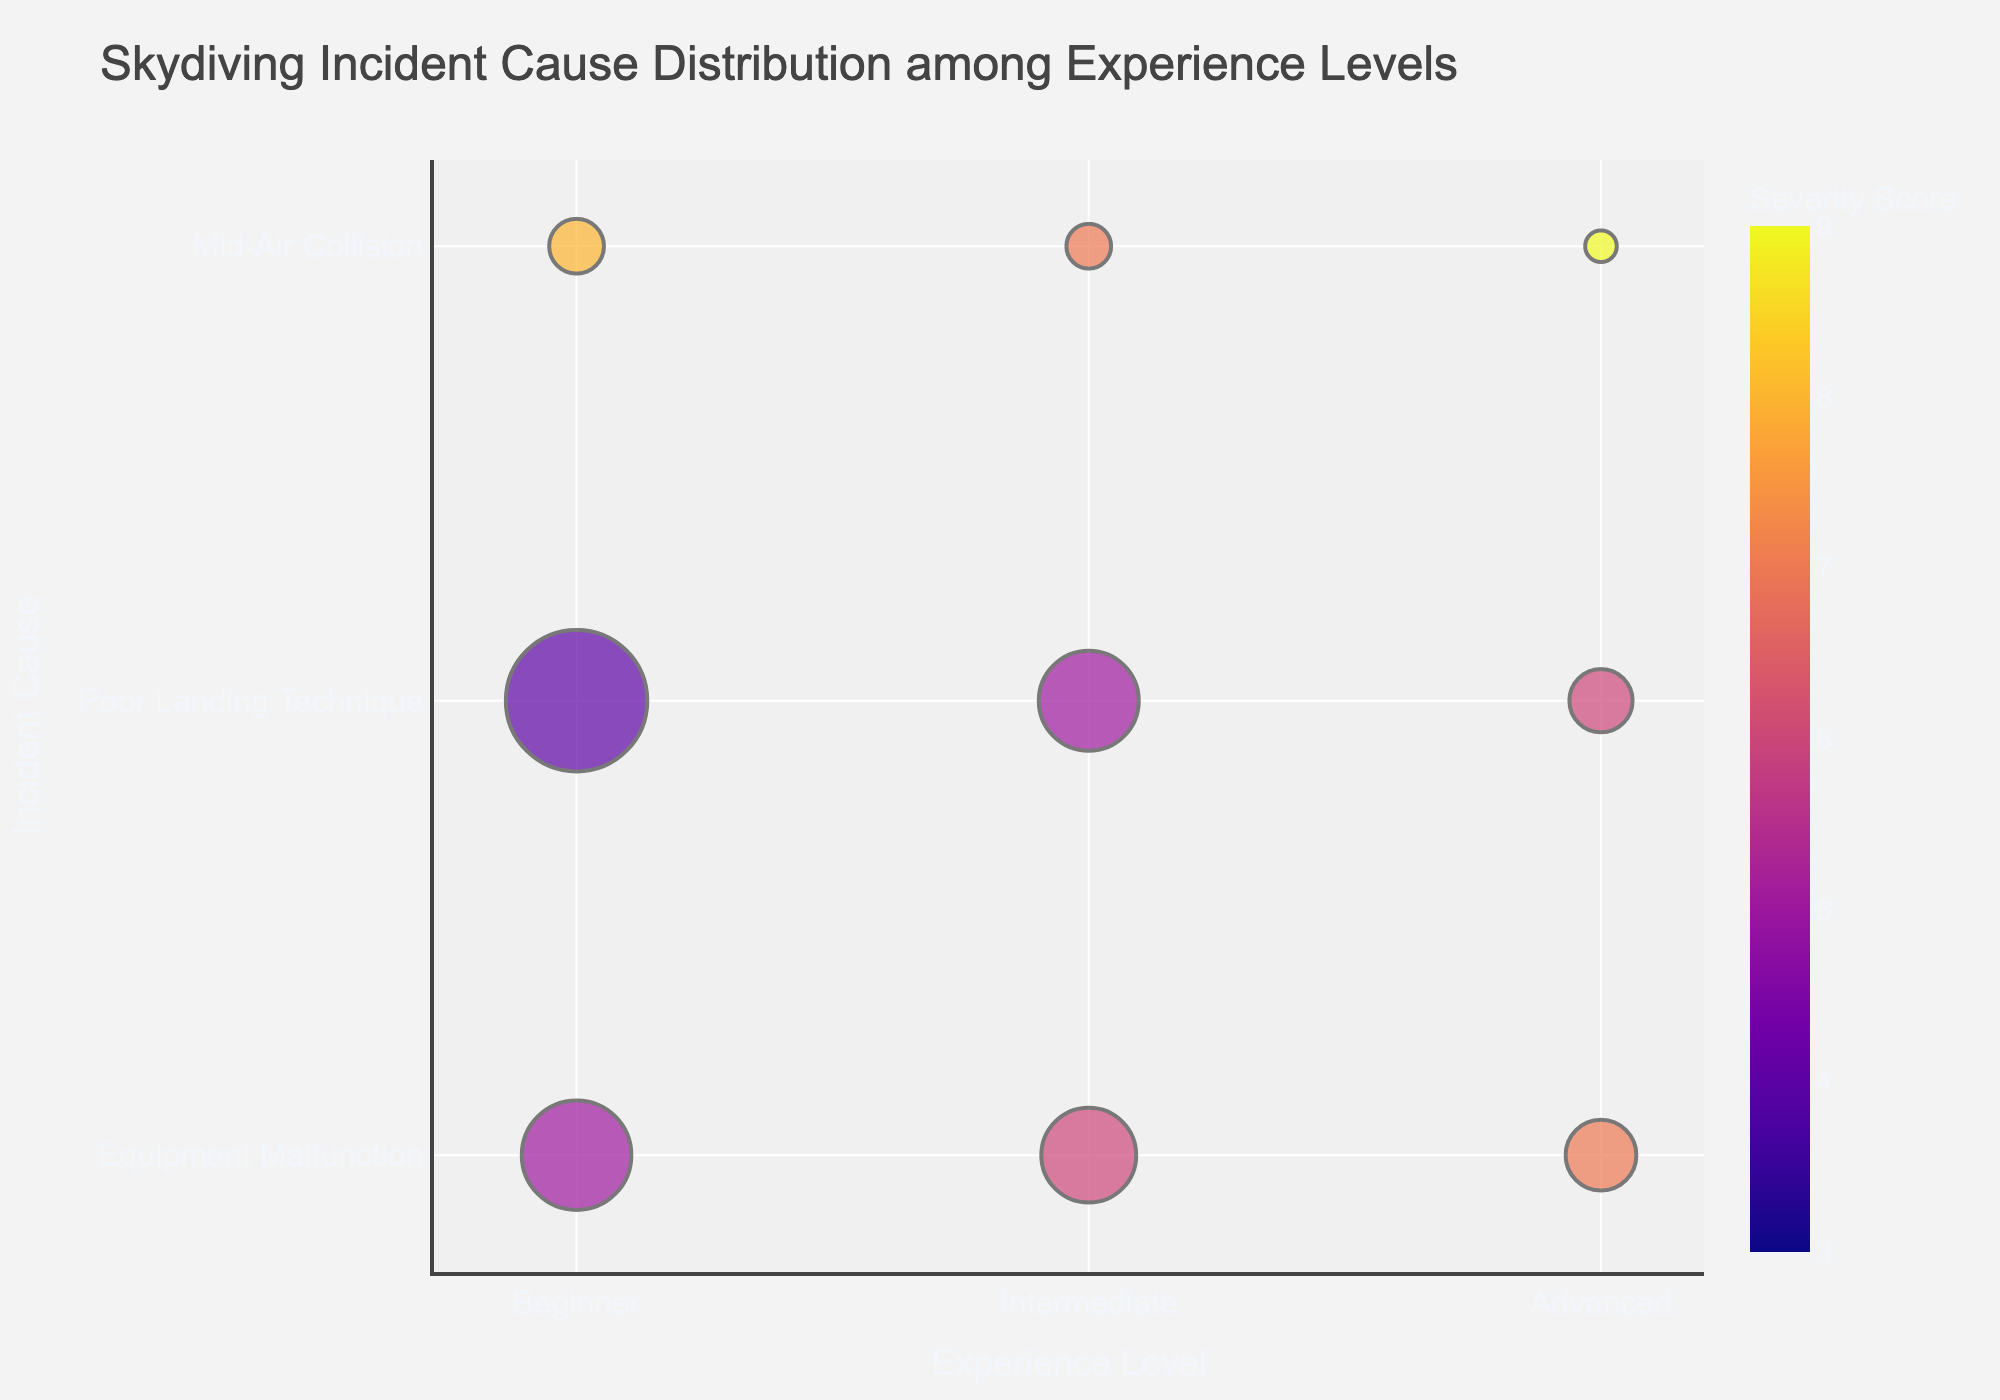What's the title of the bubble chart? The title of the bubble chart is usually displayed at the top of the figure. In this case, it specifically tells us what the chart is about.
Answer: Skydiving Incident Cause Distribution among Experience Levels How many incident causes are there for beginners? Look at the bubbles on the "Beginner" row in the y-axis. Count the distinct incident causes linked to this experience level.
Answer: 3 Which experience level has the highest number of incidents for "Poor Landing Technique"? Examine the size of the bubbles corresponding to "Poor Landing Technique" along the y-axis for each experience level. The largest bubble indicates the highest number of incidents.
Answer: Beginner What's the total number of incidents for "Equipment Malfunction" across all experience levels? Add up the sizes of the bubbles aligned with "Equipment Malfunction" for all experience levels. The individual counts are 12, 9, and 5. Their sum is 12 + 9 + 5 = 26.
Answer: 26 Which incident cause has the highest severity for advanced skydivers? Look at the "Advanced" row, then identify the bubble with the highest color intensity (which corresponds to higher severity).
Answer: Mid-Air Collision Compare the number of incidents for "Mid-Air Collision" between beginners and intermediates. Which group has more incidents? Identify the bubbles representing "Mid-Air Collision" for beginners and intermediates, then compare their sizes. Beginners have 3 incidents, while intermediates have 2.
Answer: Beginners What is the average severity score for "Poor Landing Technique" incidents? Note the severity for "Poor Landing Technique" across all experience levels (4, 5, and 6), then compute the average: (4 + 5 + 6) / 3 = 5.
Answer: 5 Which incident cause has both the lowest number and the highest severity for advanced skydivers? For advanced skydivers, identify the bubble corresponding to each incident cause. The smallest bubble with the highest color intensity indicates 1 incident and severity 9.
Answer: Mid-Air Collision How does the number of incidents for "Equipment Malfunction" compare between beginners and advanced skydivers? Look at the sizes of the bubbles for "Equipment Malfunction" in the beginner and advanced rows. Beginners have 12 incidents, and advanced skydivers have 5. 12 is greater than 5.
Answer: Beginners have more incidents Considering only intermediate and advanced skydivers, which group has more total incidents? Sum the incidents for intermediate (9+10+2) and advanced (5+4+1). Intermediate total is 21, and advanced total is 10.
Answer: Intermediates 